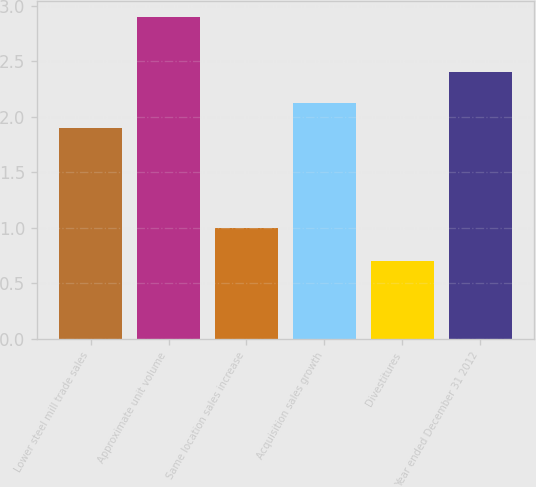Convert chart. <chart><loc_0><loc_0><loc_500><loc_500><bar_chart><fcel>Lower steel mill trade sales<fcel>Approximate unit volume<fcel>Same location sales increase<fcel>Acquisition sales growth<fcel>Divestitures<fcel>Year ended December 31 2012<nl><fcel>1.9<fcel>2.9<fcel>1<fcel>2.12<fcel>0.7<fcel>2.4<nl></chart> 